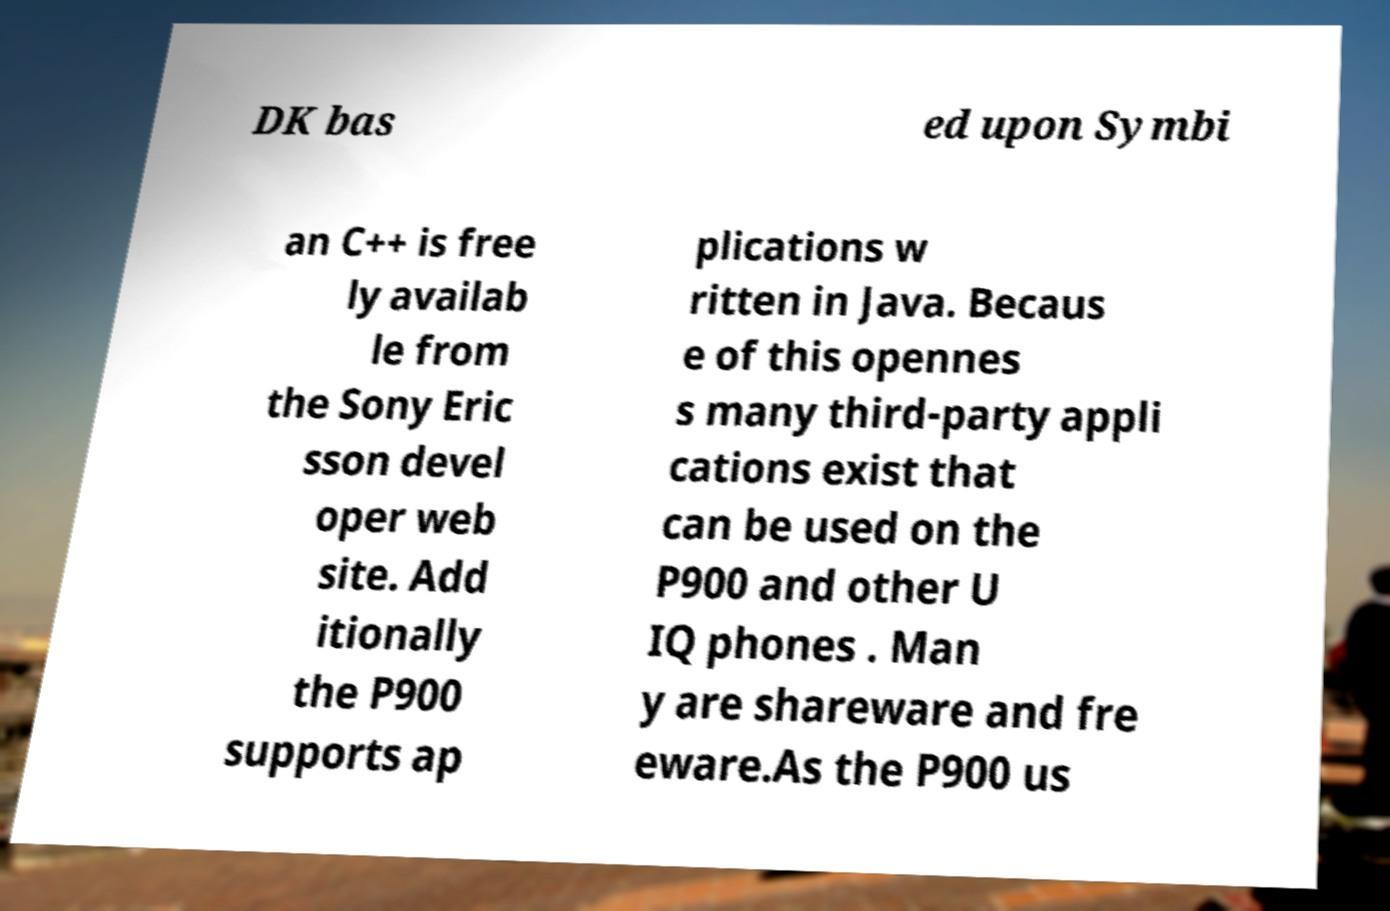Can you read and provide the text displayed in the image?This photo seems to have some interesting text. Can you extract and type it out for me? DK bas ed upon Symbi an C++ is free ly availab le from the Sony Eric sson devel oper web site. Add itionally the P900 supports ap plications w ritten in Java. Becaus e of this opennes s many third-party appli cations exist that can be used on the P900 and other U IQ phones . Man y are shareware and fre eware.As the P900 us 